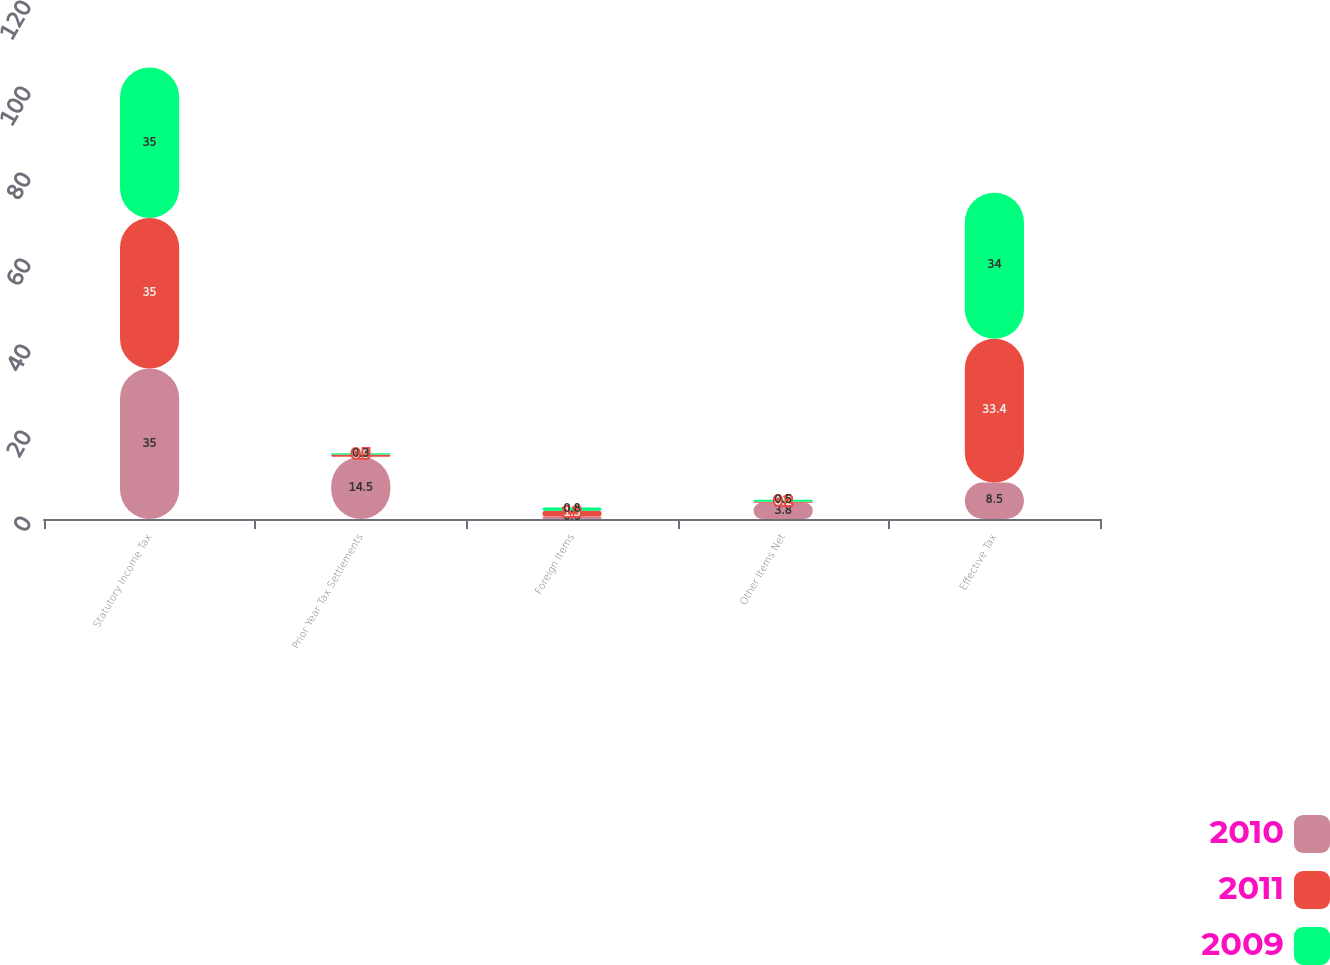<chart> <loc_0><loc_0><loc_500><loc_500><stacked_bar_chart><ecel><fcel>Statutory Income Tax<fcel>Prior Year Tax Settlements<fcel>Foreign Items<fcel>Other Items Net<fcel>Effective Tax<nl><fcel>2010<fcel>35<fcel>14.5<fcel>0.6<fcel>3.8<fcel>8.5<nl><fcel>2011<fcel>35<fcel>0.5<fcel>1.3<fcel>0.2<fcel>33.4<nl><fcel>2009<fcel>35<fcel>0.3<fcel>0.8<fcel>0.5<fcel>34<nl></chart> 